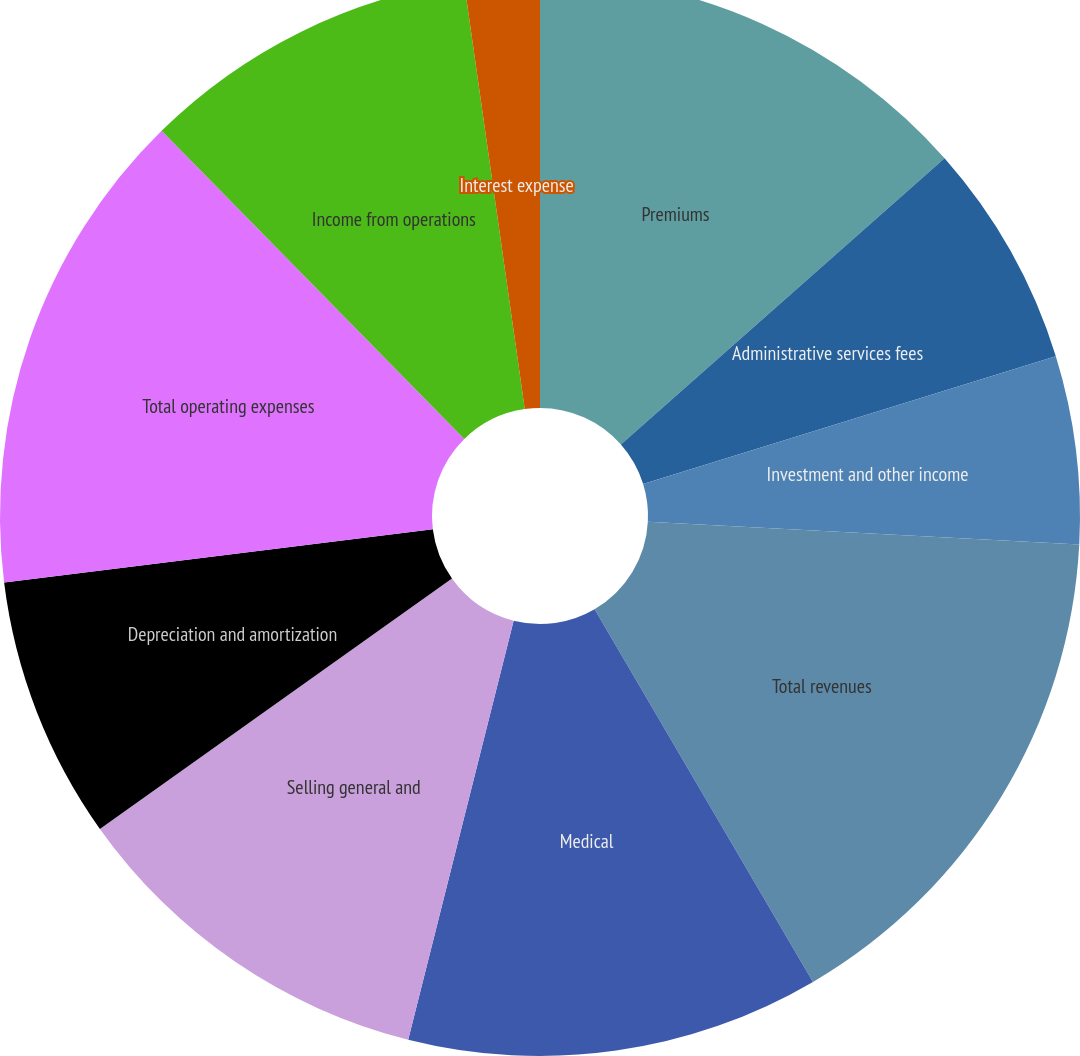Convert chart. <chart><loc_0><loc_0><loc_500><loc_500><pie_chart><fcel>Premiums<fcel>Administrative services fees<fcel>Investment and other income<fcel>Total revenues<fcel>Medical<fcel>Selling general and<fcel>Depreciation and amortization<fcel>Total operating expenses<fcel>Income from operations<fcel>Interest expense<nl><fcel>13.48%<fcel>6.74%<fcel>5.62%<fcel>15.73%<fcel>12.36%<fcel>11.24%<fcel>7.87%<fcel>14.61%<fcel>10.11%<fcel>2.25%<nl></chart> 